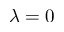<formula> <loc_0><loc_0><loc_500><loc_500>\lambda = 0</formula> 